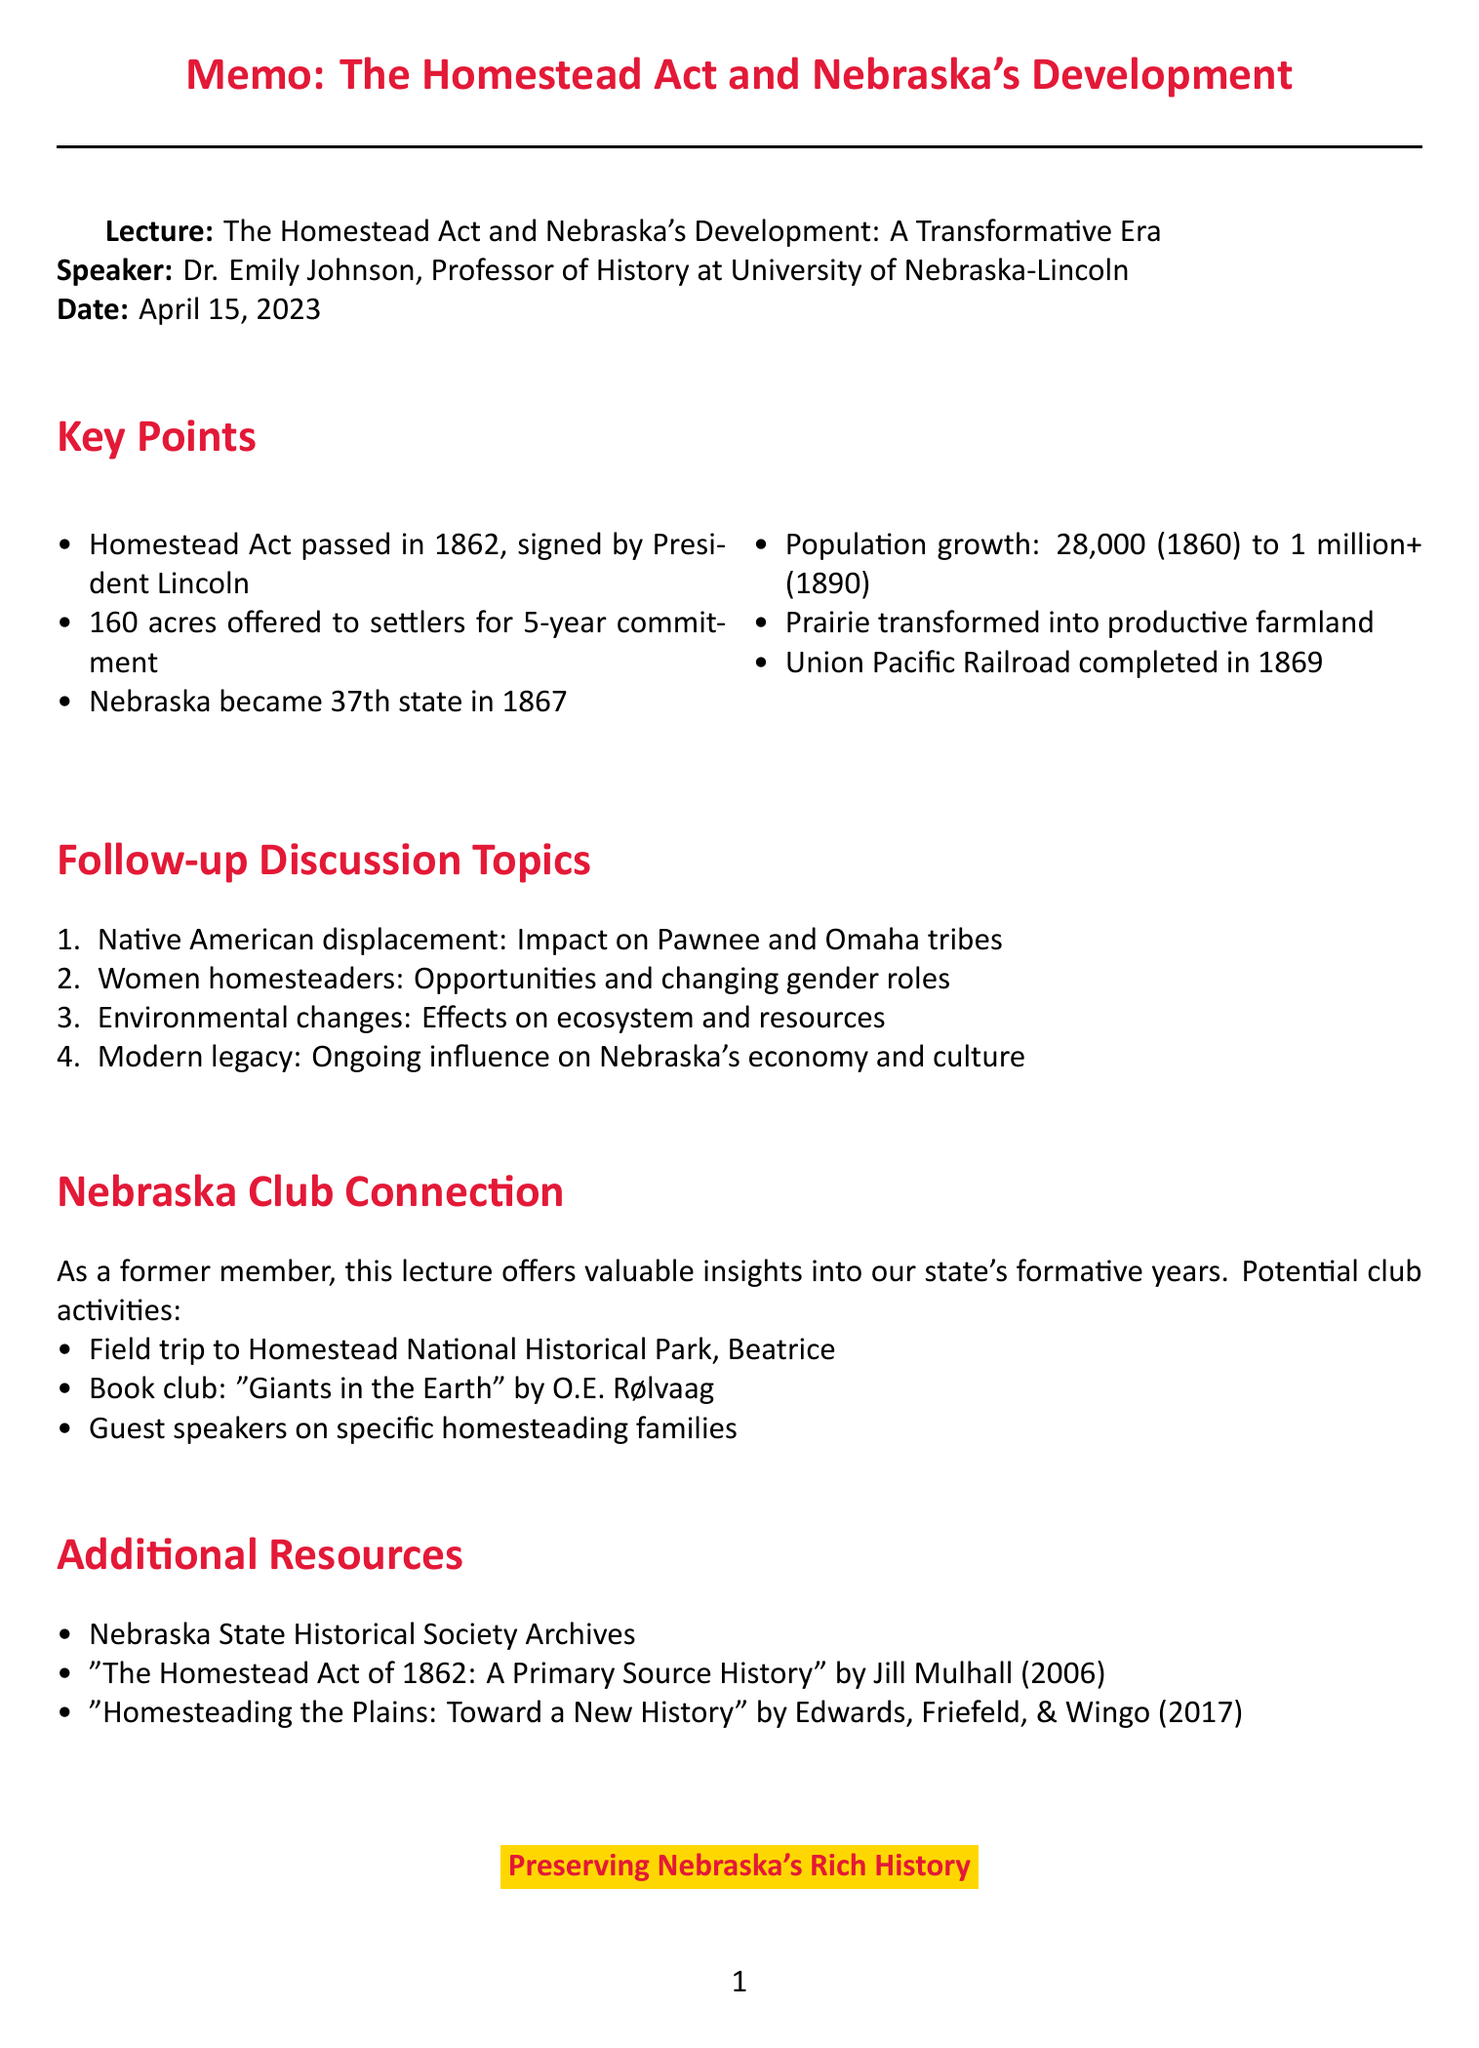What is the title of the lecture? The title of the lecture is specified in the document under the section "Lecture."
Answer: The Homestead Act and Nebraska's Development: A Transformative Era Who was the speaker at the lecture? The speaker is mentioned right after the lecture title.
Answer: Dr. Emily Johnson What date was the lecture held? The date of the lecture is listed directly beneath the speaker's name.
Answer: April 15, 2023 How many acres of land were offered to settlers under the Homestead Act? The key points section provides the amount of land for settlers.
Answer: 160 acres What was Nebraska's population in 1860? The population growth point provides the number for 1860.
Answer: Approximately 28,000 What year did Nebraska become a state? The document specifies this information in the key points section.
Answer: 1867 What railroad was completed in 1869? The key points section refers to the specific railroad that was completed.
Answer: Union Pacific Railroad What is one suggested activity for the Nebraska Club mentioned in the memo? The Nebraska Club connection section lists potential activities.
Answer: Organize field trips to Homestead National Historical Park in Beatrice What is one additional resource listed in the document? The Additional Resources section provides titles of resources related to the topic.
Answer: Nebraska State Historical Society Archives 